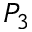<formula> <loc_0><loc_0><loc_500><loc_500>P _ { 3 }</formula> 